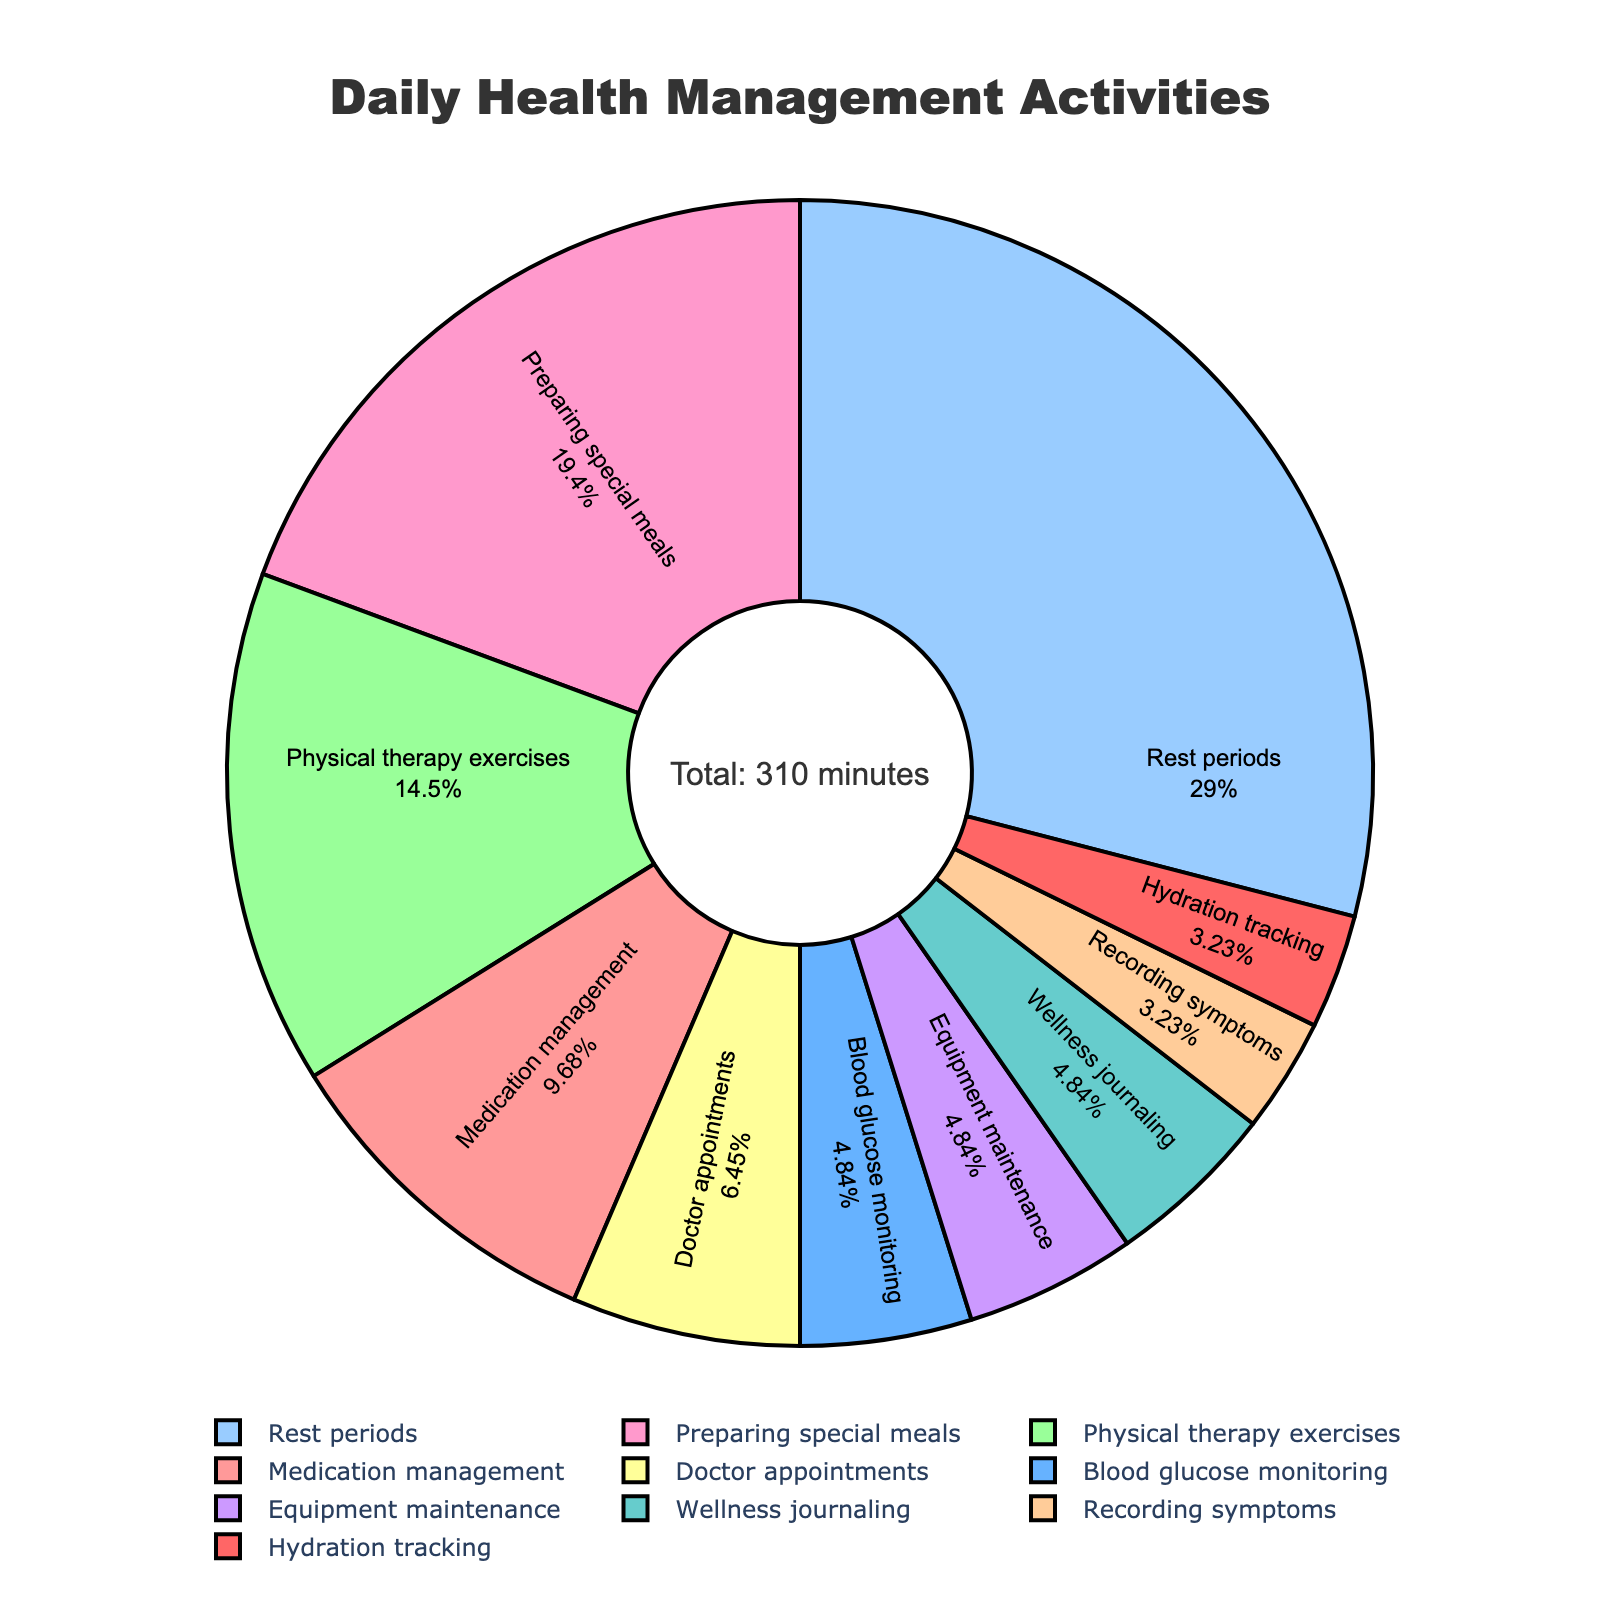What activity takes up the largest proportion of daily health management? The pie chart shows various activities and their corresponding proportions based on the time allocated. The segment labeled "Rest periods" seems the largest.
Answer: Rest periods Which activity requires more time, medication management or blood glucose monitoring? Refer to the sizes of the segments for "Medication management" and "Blood glucose monitoring". "Medication management" is larger.
Answer: Medication management How much total time is spent on blood glucose monitoring and equipment maintenance combined? Blood glucose monitoring is 15 minutes and equipment maintenance is 15 minutes. Summing these gives 15 + 15 = 30 minutes.
Answer: 30 minutes What percentage of the daily time is spent on preparing special meals? Look at the text within the segment labeled "Preparing special meals". It shows the proportion of the total time, which is calculated as (60/310)*100 = 19.35%.
Answer: 19.35% How does the time spent on doctor appointments compare to the time spent on wellness journaling? Compare the sizes of the segments or the given values. Doctor appointments are 20 minutes, and wellness journaling is 15 minutes. Therefore, doctor appointments take slightly more time.
Answer: Doctor appointments Is the time spent on hydration tracking more or less than 10% of the total daily health management time? Hydration tracking is 10 minutes. The total time for all activities is 310 minutes. Calculate the percentage (10/310)*100 ≈ 3.23%. This is less than 10%.
Answer: Less What is the color associated with the "Physical therapy exercises" segment? Look at the color legend and match the segment labeled "Physical therapy exercises" with its color. The segment is likely colored in one of the shades of the provided palette.
Answer: Blue Between recording symptoms and hydration tracking, which activity takes less time, and by how much? Recording symptoms take 10 minutes, and hydration tracking also takes 10 minutes. Therefore, they take an equal amount of time.
Answer: Equal What is the total time spent on activities excluding rest periods? Subtract the time for rest periods from the total time. The total time is 310 minutes, and rest periods are 90 minutes. Thus, 310 - 90 = 220 minutes.
Answer: 220 minutes 